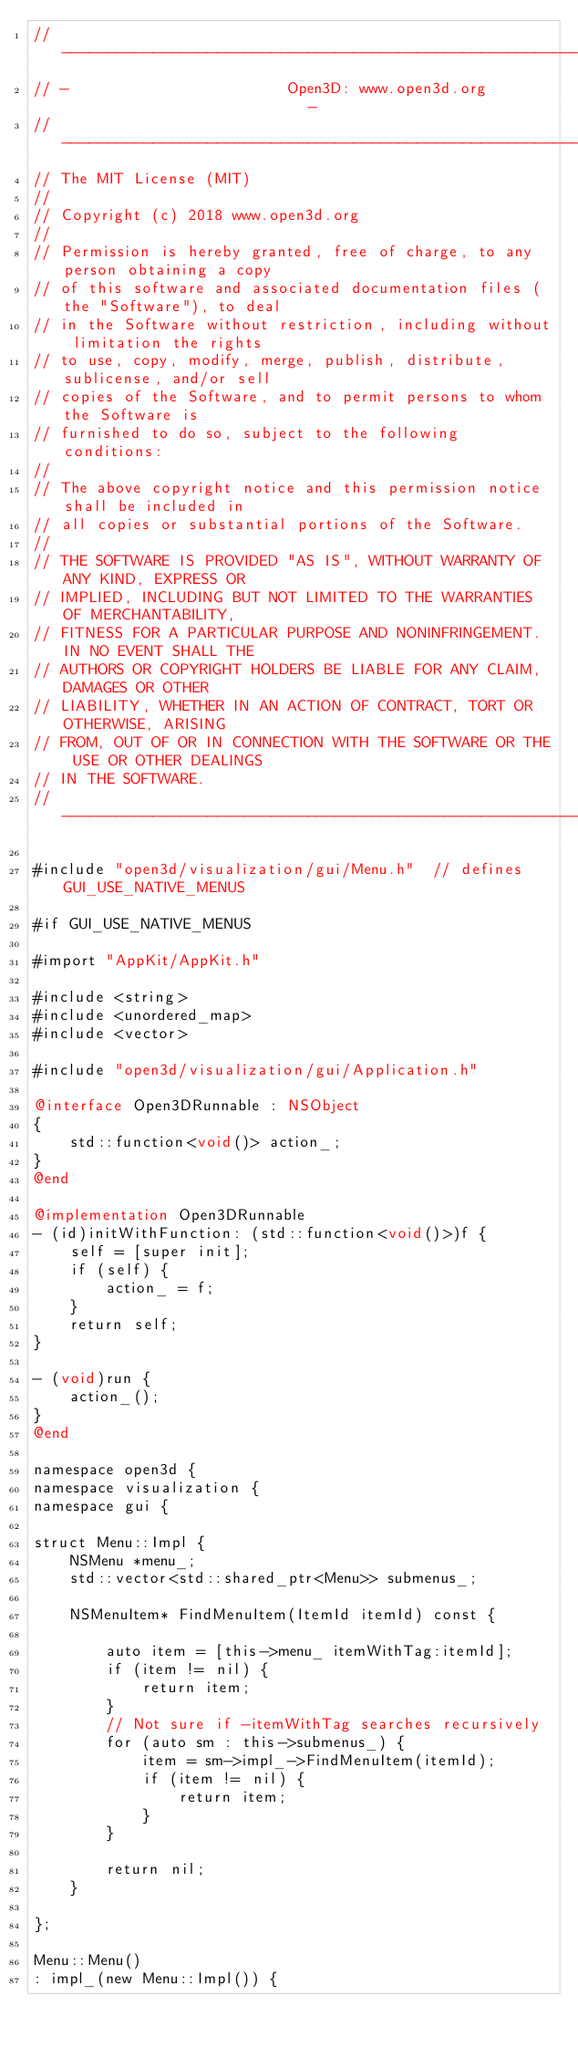<code> <loc_0><loc_0><loc_500><loc_500><_ObjectiveC_>// ----------------------------------------------------------------------------
// -                        Open3D: www.open3d.org                            -
// ----------------------------------------------------------------------------
// The MIT License (MIT)
//
// Copyright (c) 2018 www.open3d.org
//
// Permission is hereby granted, free of charge, to any person obtaining a copy
// of this software and associated documentation files (the "Software"), to deal
// in the Software without restriction, including without limitation the rights
// to use, copy, modify, merge, publish, distribute, sublicense, and/or sell
// copies of the Software, and to permit persons to whom the Software is
// furnished to do so, subject to the following conditions:
//
// The above copyright notice and this permission notice shall be included in
// all copies or substantial portions of the Software.
//
// THE SOFTWARE IS PROVIDED "AS IS", WITHOUT WARRANTY OF ANY KIND, EXPRESS OR
// IMPLIED, INCLUDING BUT NOT LIMITED TO THE WARRANTIES OF MERCHANTABILITY,
// FITNESS FOR A PARTICULAR PURPOSE AND NONINFRINGEMENT. IN NO EVENT SHALL THE
// AUTHORS OR COPYRIGHT HOLDERS BE LIABLE FOR ANY CLAIM, DAMAGES OR OTHER
// LIABILITY, WHETHER IN AN ACTION OF CONTRACT, TORT OR OTHERWISE, ARISING
// FROM, OUT OF OR IN CONNECTION WITH THE SOFTWARE OR THE USE OR OTHER DEALINGS
// IN THE SOFTWARE.
// ----------------------------------------------------------------------------

#include "open3d/visualization/gui/Menu.h"  // defines GUI_USE_NATIVE_MENUS

#if GUI_USE_NATIVE_MENUS

#import "AppKit/AppKit.h"

#include <string>
#include <unordered_map>
#include <vector>

#include "open3d/visualization/gui/Application.h"

@interface Open3DRunnable : NSObject
{
    std::function<void()> action_;
}
@end

@implementation Open3DRunnable
- (id)initWithFunction: (std::function<void()>)f {
    self = [super init];
    if (self) {
        action_ = f;
    }
    return self;
}

- (void)run {
    action_();
}
@end

namespace open3d {
namespace visualization {
namespace gui {

struct Menu::Impl {
    NSMenu *menu_;
    std::vector<std::shared_ptr<Menu>> submenus_;

    NSMenuItem* FindMenuItem(ItemId itemId) const {

        auto item = [this->menu_ itemWithTag:itemId];
        if (item != nil) {
            return item;
        }
        // Not sure if -itemWithTag searches recursively
        for (auto sm : this->submenus_) {
            item = sm->impl_->FindMenuItem(itemId);
            if (item != nil) {
                return item;
            }
        }

        return nil;
    }

};

Menu::Menu()
: impl_(new Menu::Impl()) {</code> 